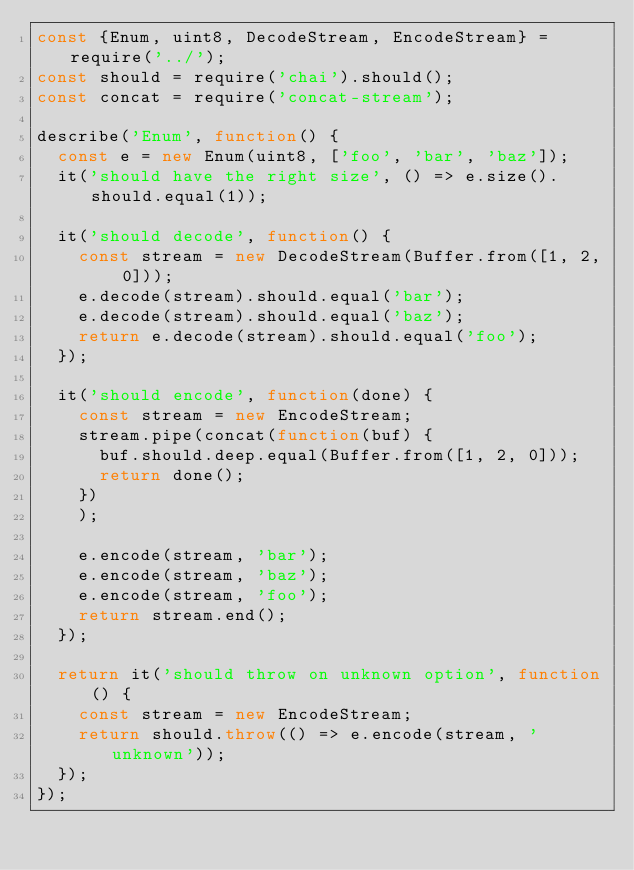<code> <loc_0><loc_0><loc_500><loc_500><_JavaScript_>const {Enum, uint8, DecodeStream, EncodeStream} = require('../');
const should = require('chai').should();
const concat = require('concat-stream');

describe('Enum', function() {
  const e = new Enum(uint8, ['foo', 'bar', 'baz']);
  it('should have the right size', () => e.size().should.equal(1));

  it('should decode', function() {
    const stream = new DecodeStream(Buffer.from([1, 2, 0]));
    e.decode(stream).should.equal('bar');
    e.decode(stream).should.equal('baz');
    return e.decode(stream).should.equal('foo');
  });

  it('should encode', function(done) {
    const stream = new EncodeStream;
    stream.pipe(concat(function(buf) {
      buf.should.deep.equal(Buffer.from([1, 2, 0]));
      return done();
    })
    );

    e.encode(stream, 'bar');
    e.encode(stream, 'baz');
    e.encode(stream, 'foo');
    return stream.end();
  });

  return it('should throw on unknown option', function() {
    const stream = new EncodeStream;
    return should.throw(() => e.encode(stream, 'unknown'));
  });
});
</code> 